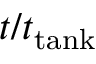<formula> <loc_0><loc_0><loc_500><loc_500>t / t _ { t a n k }</formula> 